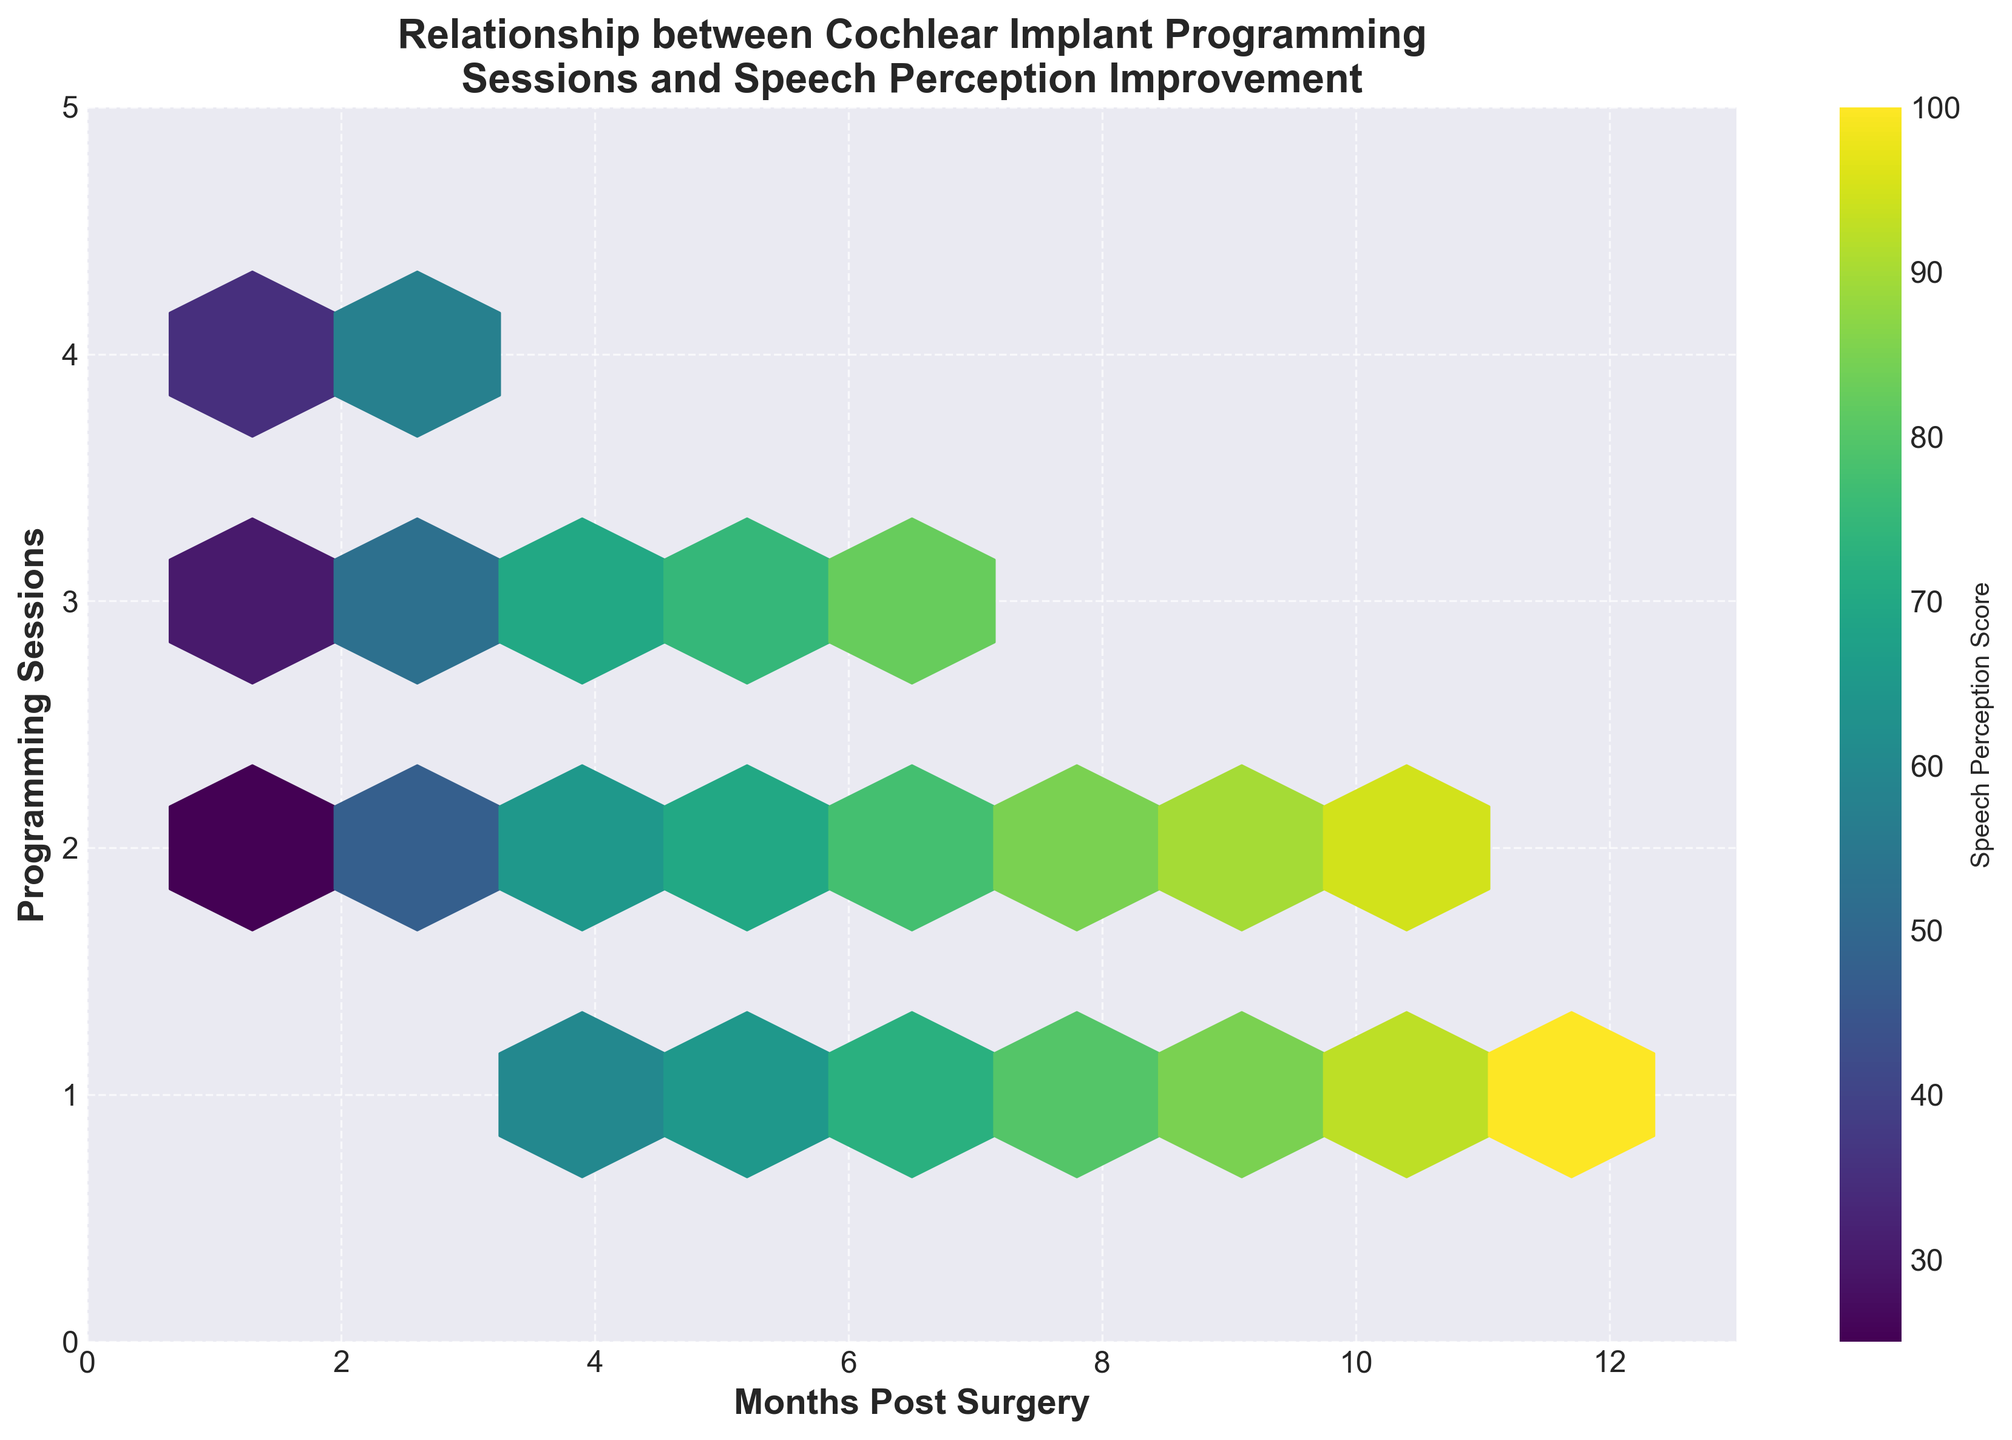What is the title of the hexbin plot? The title of the hexbin plot is displayed at the top and summarizes the plot's content. The plot's title is "Relationship between Cochlear Implant Programming Sessions and Speech Perception Improvement".
Answer: Relationship between Cochlear Implant Programming Sessions and Speech Perception Improvement What are the x-axis and y-axis labels? The x-axis and y-axis labels help identify what each axis represents. The x-axis is labeled "Months Post Surgery" and the y-axis is labeled "Programming Sessions".
Answer: Months Post Surgery, Programming Sessions Which color represents higher speech perception scores in the plot? In the hexbin plot, color represents the speech perception score, with higher scores typically represented by a darker color on a viridis colormap.
Answer: Darker color At which number of months post-surgery do the most programming sessions occur? By observing the x-axis for months and the density of hexagons on the y-axis, the most programming sessions occur around 5 to 7 months post-surgery, indicated by denser hexbin areas.
Answer: 5 to 7 months Which month post-surgery has the highest speech perception score? Looking for the darker hexagonal areas on the x-axis and consulting the color bar, the highest speech perception score appears at 12 months post-surgery.
Answer: 12 months How does the number of programming sessions change from 1 to 12 months post-surgery? By checking the y-axis and the density of hexagons over the months (x-axis), the number of programming sessions generally decreases after the initial few months.
Answer: Decreases Compare the speech perception score at 1 month and 12 months post-surgery. Reference the color bar and the hexbin plot, the speech perception score at 1 month post-surgery is much lower compared to that at 12 months post-surgery (100 at 12 months).
Answer: Score is lower at 1 month What is the general trend in speech perception improvement over time? Utilizing the color of hexagons and the timeline on the x-axis, a clear trend of improvement in speech perception scores from 1 month to 12 months post-surgery is observable.
Answer: Improvement trend What can you infer about the relationship between the frequency of programming sessions and speech perception improvement? By assessing hexbin density and related speech perception scores, an inverse relationship is noticeable as programming sessions decrease, speech perception scores improve over time.
Answer: Inverse relationship 